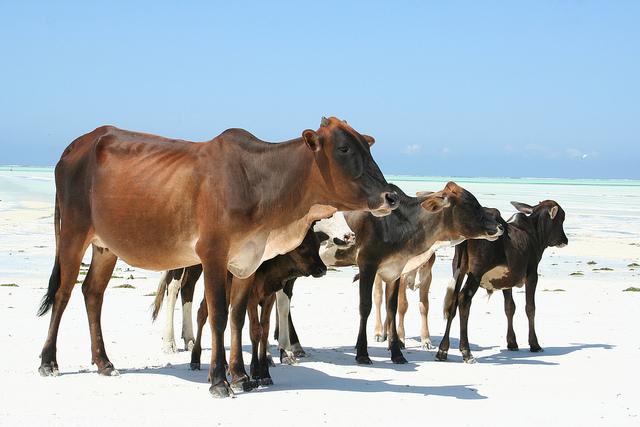Where are these cows?
Keep it brief. Beach. Are these cows ready to fight?
Concise answer only. No. How many big cows are there?
Concise answer only. 1. 